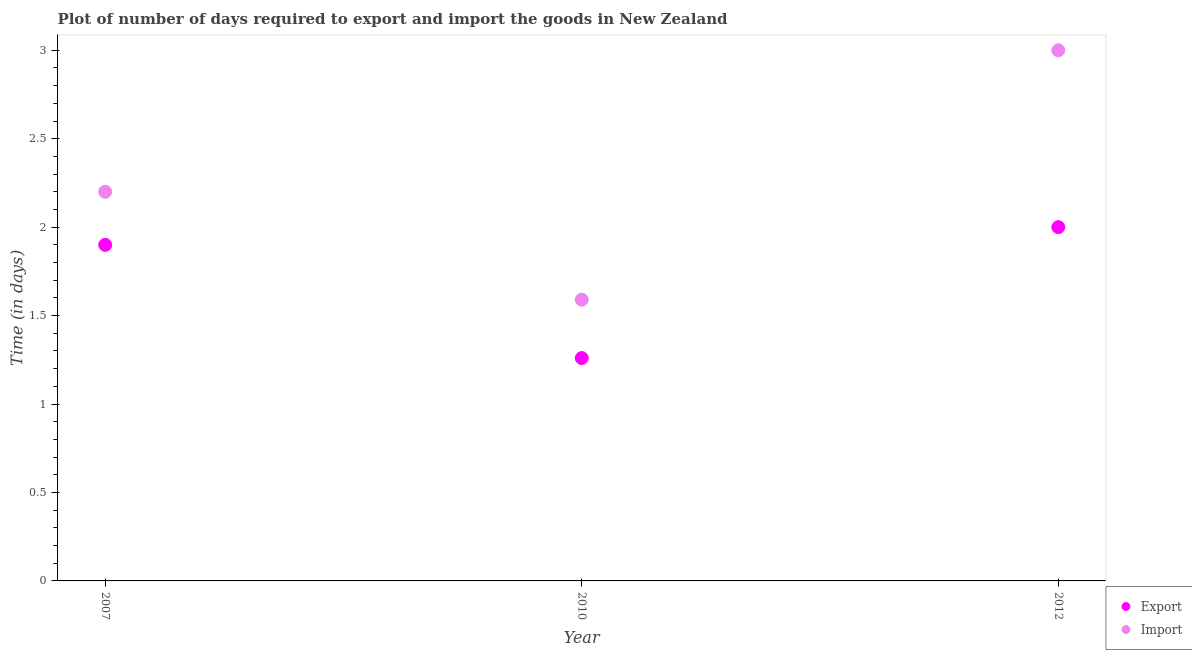What is the time required to export in 2012?
Provide a short and direct response. 2. Across all years, what is the maximum time required to import?
Your answer should be very brief. 3. Across all years, what is the minimum time required to import?
Give a very brief answer. 1.59. What is the total time required to import in the graph?
Offer a terse response. 6.79. What is the difference between the time required to export in 2010 and that in 2012?
Offer a very short reply. -0.74. What is the difference between the time required to import in 2007 and the time required to export in 2010?
Your response must be concise. 0.94. What is the average time required to export per year?
Provide a succinct answer. 1.72. In the year 2012, what is the difference between the time required to export and time required to import?
Give a very brief answer. -1. In how many years, is the time required to import greater than 1.7 days?
Provide a succinct answer. 2. What is the ratio of the time required to import in 2007 to that in 2010?
Ensure brevity in your answer.  1.38. Is the time required to export in 2007 less than that in 2012?
Your response must be concise. Yes. Is the difference between the time required to export in 2007 and 2012 greater than the difference between the time required to import in 2007 and 2012?
Offer a very short reply. Yes. What is the difference between the highest and the second highest time required to export?
Offer a terse response. 0.1. What is the difference between the highest and the lowest time required to export?
Make the answer very short. 0.74. In how many years, is the time required to import greater than the average time required to import taken over all years?
Your answer should be compact. 1. Is the time required to import strictly greater than the time required to export over the years?
Offer a very short reply. Yes. How many years are there in the graph?
Provide a short and direct response. 3. Where does the legend appear in the graph?
Your response must be concise. Bottom right. How are the legend labels stacked?
Keep it short and to the point. Vertical. What is the title of the graph?
Offer a terse response. Plot of number of days required to export and import the goods in New Zealand. Does "All education staff compensation" appear as one of the legend labels in the graph?
Make the answer very short. No. What is the label or title of the X-axis?
Give a very brief answer. Year. What is the label or title of the Y-axis?
Offer a terse response. Time (in days). What is the Time (in days) in Export in 2010?
Your response must be concise. 1.26. What is the Time (in days) in Import in 2010?
Ensure brevity in your answer.  1.59. What is the Time (in days) of Export in 2012?
Offer a very short reply. 2. What is the Time (in days) of Import in 2012?
Your response must be concise. 3. Across all years, what is the maximum Time (in days) in Export?
Provide a succinct answer. 2. Across all years, what is the minimum Time (in days) in Export?
Ensure brevity in your answer.  1.26. Across all years, what is the minimum Time (in days) of Import?
Give a very brief answer. 1.59. What is the total Time (in days) of Export in the graph?
Make the answer very short. 5.16. What is the total Time (in days) of Import in the graph?
Keep it short and to the point. 6.79. What is the difference between the Time (in days) of Export in 2007 and that in 2010?
Offer a terse response. 0.64. What is the difference between the Time (in days) of Import in 2007 and that in 2010?
Offer a very short reply. 0.61. What is the difference between the Time (in days) of Export in 2007 and that in 2012?
Offer a very short reply. -0.1. What is the difference between the Time (in days) of Import in 2007 and that in 2012?
Make the answer very short. -0.8. What is the difference between the Time (in days) of Export in 2010 and that in 2012?
Your answer should be compact. -0.74. What is the difference between the Time (in days) of Import in 2010 and that in 2012?
Ensure brevity in your answer.  -1.41. What is the difference between the Time (in days) of Export in 2007 and the Time (in days) of Import in 2010?
Provide a short and direct response. 0.31. What is the difference between the Time (in days) in Export in 2010 and the Time (in days) in Import in 2012?
Your answer should be compact. -1.74. What is the average Time (in days) of Export per year?
Make the answer very short. 1.72. What is the average Time (in days) in Import per year?
Provide a succinct answer. 2.26. In the year 2010, what is the difference between the Time (in days) of Export and Time (in days) of Import?
Offer a very short reply. -0.33. What is the ratio of the Time (in days) in Export in 2007 to that in 2010?
Offer a terse response. 1.51. What is the ratio of the Time (in days) of Import in 2007 to that in 2010?
Offer a terse response. 1.38. What is the ratio of the Time (in days) in Export in 2007 to that in 2012?
Give a very brief answer. 0.95. What is the ratio of the Time (in days) in Import in 2007 to that in 2012?
Offer a terse response. 0.73. What is the ratio of the Time (in days) of Export in 2010 to that in 2012?
Offer a very short reply. 0.63. What is the ratio of the Time (in days) of Import in 2010 to that in 2012?
Your answer should be very brief. 0.53. What is the difference between the highest and the second highest Time (in days) of Import?
Give a very brief answer. 0.8. What is the difference between the highest and the lowest Time (in days) in Export?
Provide a succinct answer. 0.74. What is the difference between the highest and the lowest Time (in days) of Import?
Make the answer very short. 1.41. 